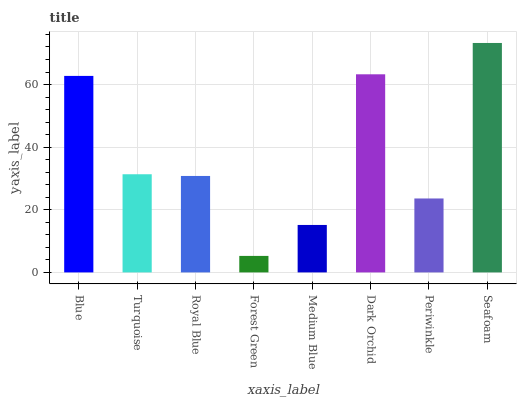Is Forest Green the minimum?
Answer yes or no. Yes. Is Seafoam the maximum?
Answer yes or no. Yes. Is Turquoise the minimum?
Answer yes or no. No. Is Turquoise the maximum?
Answer yes or no. No. Is Blue greater than Turquoise?
Answer yes or no. Yes. Is Turquoise less than Blue?
Answer yes or no. Yes. Is Turquoise greater than Blue?
Answer yes or no. No. Is Blue less than Turquoise?
Answer yes or no. No. Is Turquoise the high median?
Answer yes or no. Yes. Is Royal Blue the low median?
Answer yes or no. Yes. Is Blue the high median?
Answer yes or no. No. Is Medium Blue the low median?
Answer yes or no. No. 